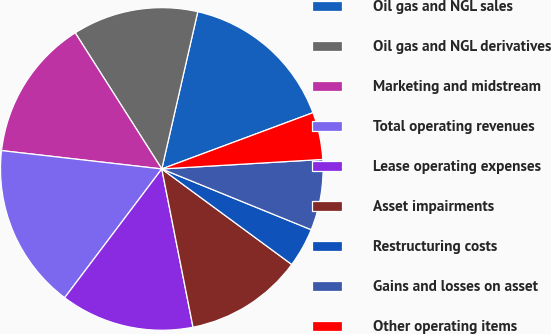Convert chart to OTSL. <chart><loc_0><loc_0><loc_500><loc_500><pie_chart><fcel>Oil gas and NGL sales<fcel>Oil gas and NGL derivatives<fcel>Marketing and midstream<fcel>Total operating revenues<fcel>Lease operating expenses<fcel>Asset impairments<fcel>Restructuring costs<fcel>Gains and losses on asset<fcel>Other operating items<nl><fcel>15.75%<fcel>12.6%<fcel>14.17%<fcel>16.53%<fcel>13.39%<fcel>11.81%<fcel>3.94%<fcel>7.09%<fcel>4.73%<nl></chart> 